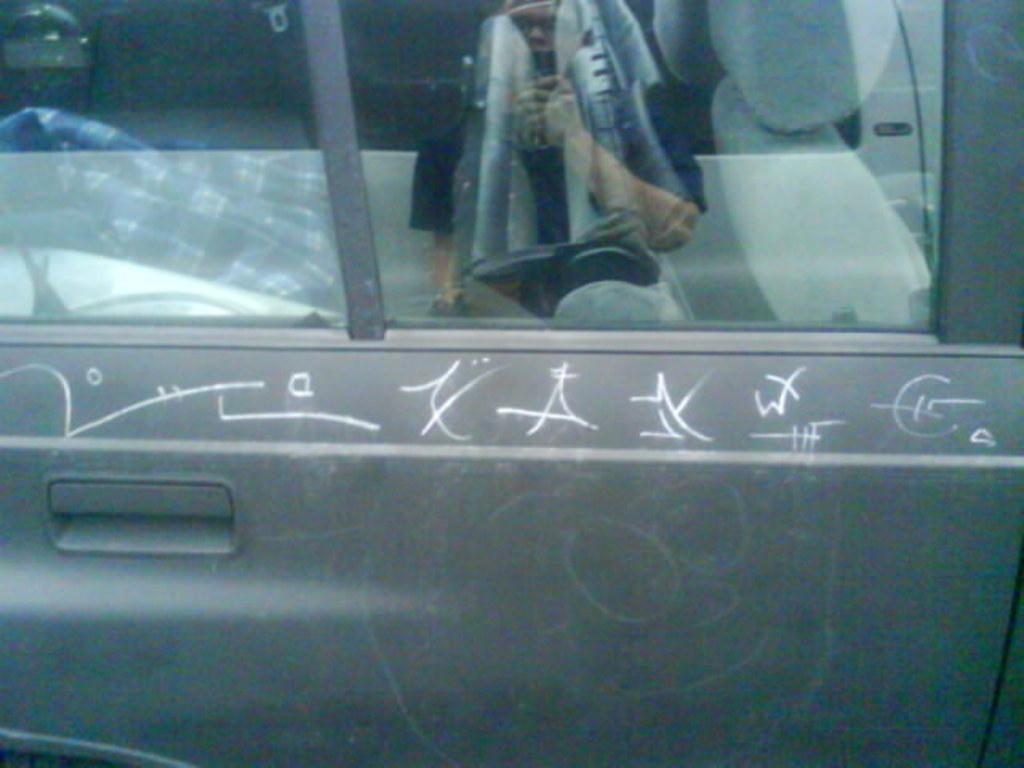Describe this image in one or two sentences. In the image there is a car door with glass windows. On the car door there is something written on it. On the glass there is a reflection of a person. 